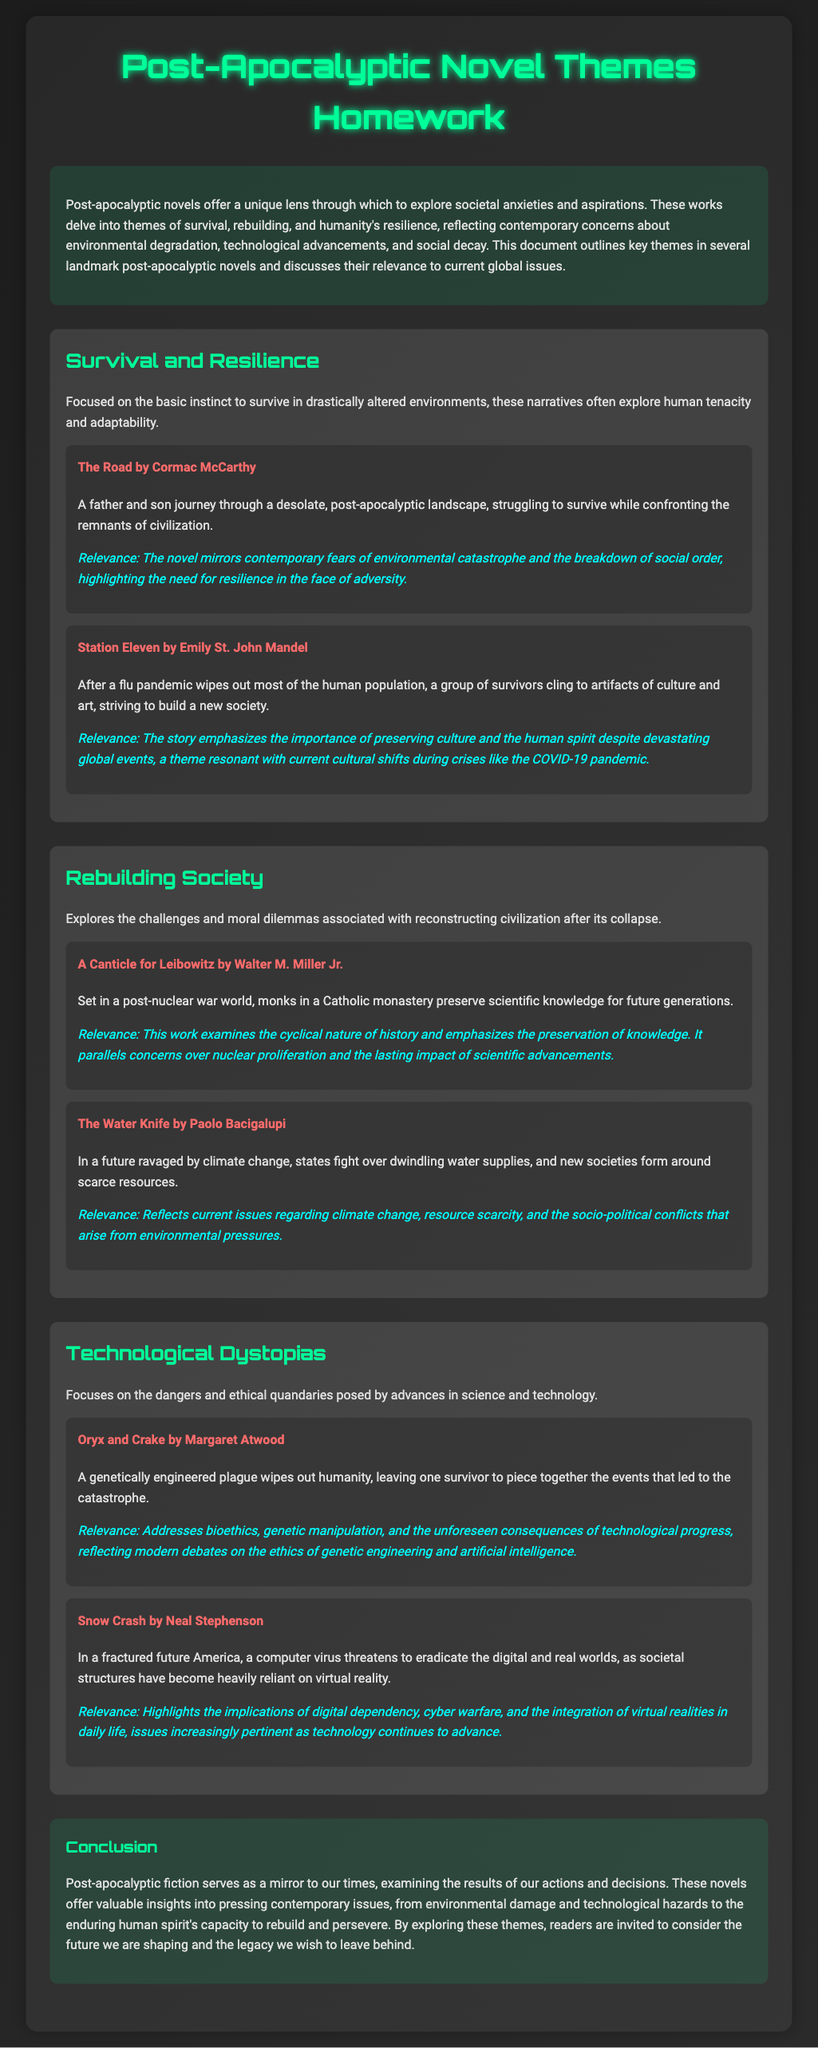What is the title of the homework document? The title is specified in the document's header.
Answer: Post-Apocalyptic Novel Themes Homework Who is the author of "The Road"? The document mentions the author alongside the novel title.
Answer: Cormac McCarthy What theme is associated with "Station Eleven"? The theme is highlighted in the context of the novel's discussion.
Answer: Survival and Resilience Which novel deals with preserving knowledge after nuclear war? The answer can be found in the specific theme discussing the novel.
Answer: A Canticle for Leibowitz What societal issue does "The Water Knife" reflect? The relevance section of the novel describes its societal issues.
Answer: Climate change What is a key focus of "Oryx and Crake"? The focus is detailed in the discussion of the novel within the document.
Answer: Genetic manipulation Which two authors are mentioned in the technological dystopias theme? The authors are listed under that specific theme.
Answer: Margaret Atwood, Neal Stephenson What year does "Station Eleven" explore after a pandemic? The year is derived from the context of the story's timeline.
Answer: Not specified What does post-apocalyptic fiction serve as a mirror to? The conclusion of the document reveals this reflection.
Answer: Our times 